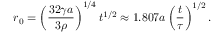Convert formula to latex. <formula><loc_0><loc_0><loc_500><loc_500>r _ { 0 } = \left ( \frac { 3 2 \gamma a } { 3 \rho } \right ) ^ { 1 / 4 } t ^ { 1 / 2 } \approx 1 . 8 0 7 a \left ( \frac { t } { \tau } \right ) ^ { 1 / 2 } .</formula> 